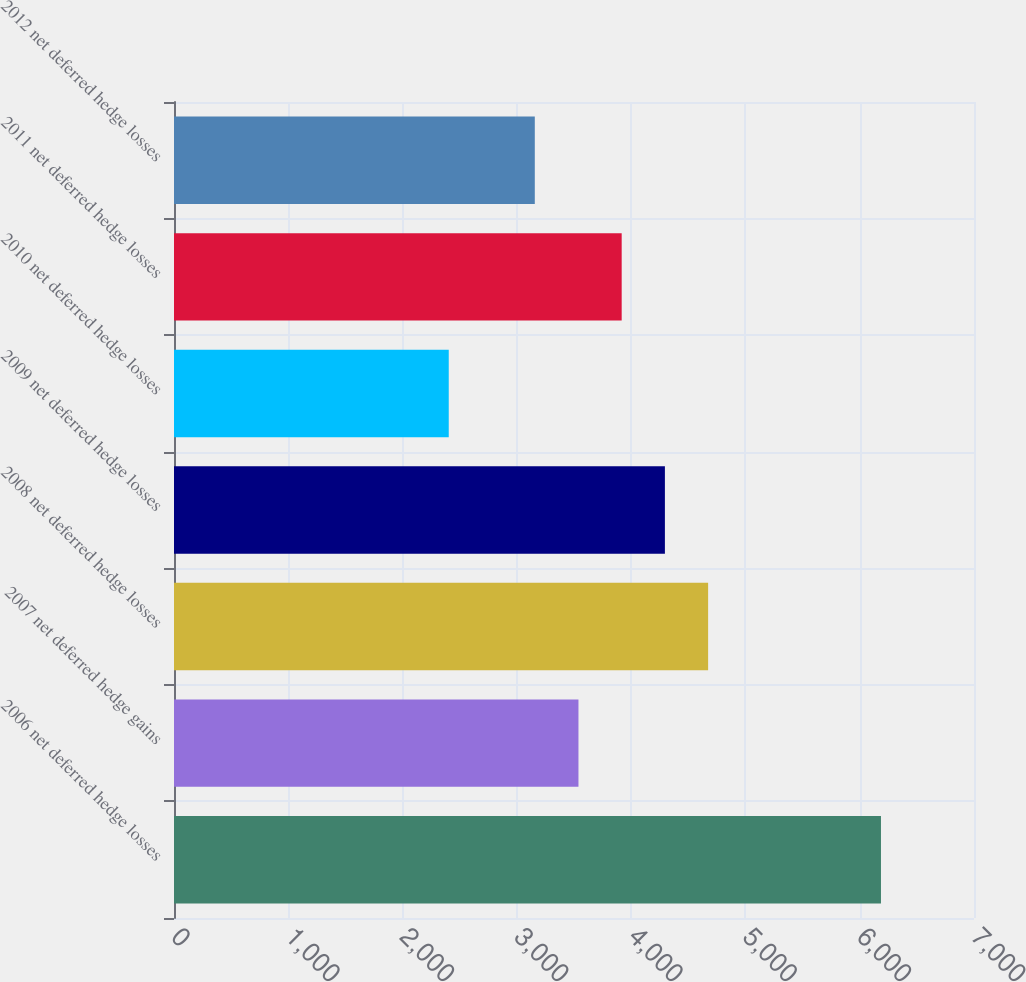<chart> <loc_0><loc_0><loc_500><loc_500><bar_chart><fcel>2006 net deferred hedge losses<fcel>2007 net deferred hedge gains<fcel>2008 net deferred hedge losses<fcel>2009 net deferred hedge losses<fcel>2010 net deferred hedge losses<fcel>2011 net deferred hedge losses<fcel>2012 net deferred hedge losses<nl><fcel>6186<fcel>3539<fcel>4673.6<fcel>4295.4<fcel>2404<fcel>3917.2<fcel>3157<nl></chart> 